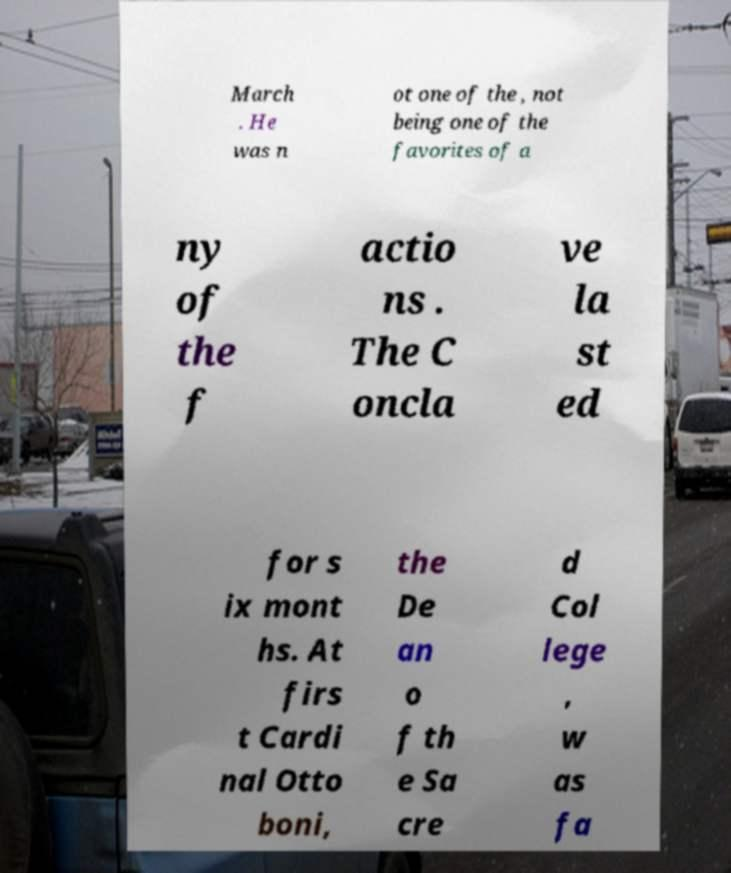Could you assist in decoding the text presented in this image and type it out clearly? March . He was n ot one of the , not being one of the favorites of a ny of the f actio ns . The C oncla ve la st ed for s ix mont hs. At firs t Cardi nal Otto boni, the De an o f th e Sa cre d Col lege , w as fa 